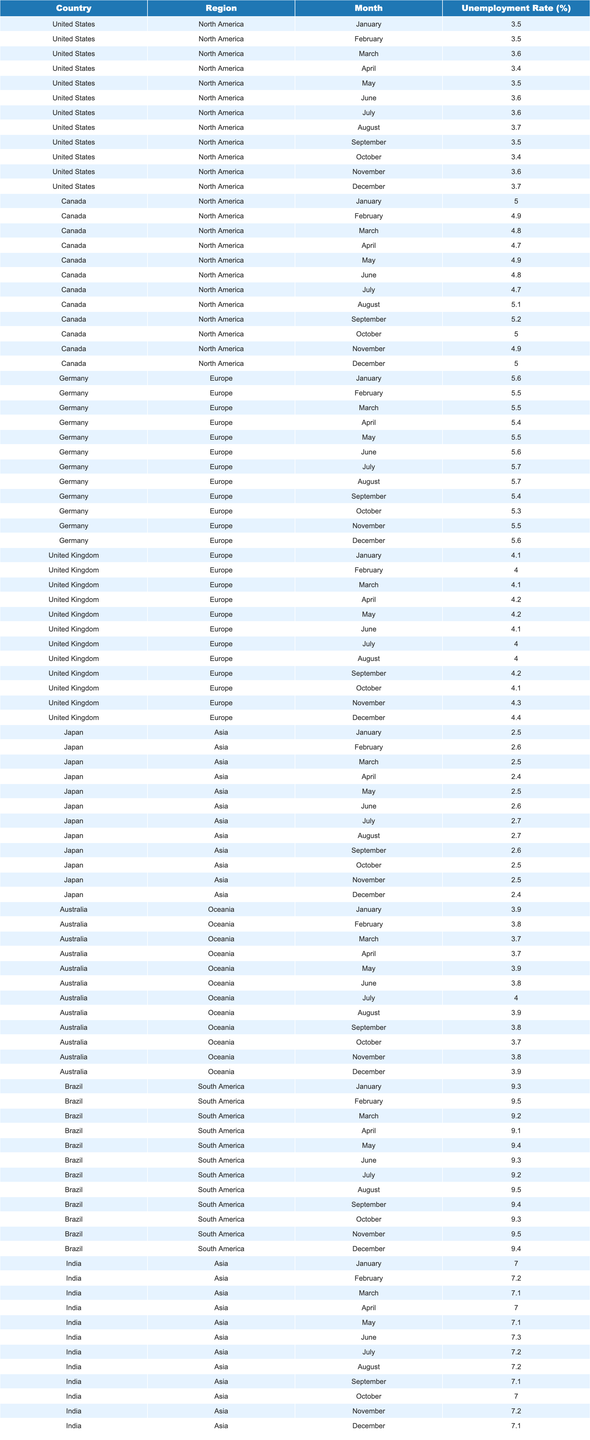What was the highest unemployment rate in Brazil in 2023? By reviewing the data for Brazil, the highest unemployment rate occurred in February at 9.5%.
Answer: 9.5% Which country had the lowest average unemployment rate in 2023? To find this, we calculate the average for each country: United States (3.55%), Japan (2.55%), Australia (3.83%), Canada (4.91%), Germany (5.42%), United Kingdom (4.14%), Brazil (9.36%), and India (7.12%). Japan has the lowest average at 2.55%.
Answer: Japan Did the unemployment rate in the United States ever exceed 3.7% during 2023? By examining the U.S. unemployment rates, the maximum recorded is 3.7% in August and December, indicating it did not exceed this value.
Answer: No What was the percentage decrease in unemployment rate in India from January to April 2023? India's unemployment rate in January was 7.0% and in April it was also 7.0%. The percentage decrease is calculated based on these numbers, which shows that there was no decrease.
Answer: 0% Which month saw the highest unemployment rate in Canada, and what was it? In analyzing the Canadian data, August has the highest unemployment rate at 5.1% during that month.
Answer: 5.1% in August What is the average unemployment rate for Europe in 2023? To find the average for Europe, we compute the mean of Germany 5.6%, 5.5%, 5.5%, 5.4%, 5.5%, 5.6%, 5.7%, 5.7%, 5.4%, 5.3%, 5.5%, 5.6% and United Kingdom 4.1%, 4.0%, 4.1%, 4.2%, 4.2%, 4.1%, 4.0%, 4.0%, 4.2%, 4.1%, 4.3%, 4.4%. Totaling to (5.5*12 + 4.1*12)/24 = 4.83 approximately.
Answer: 4.83% Which region experienced the highest unemployment rate in December 2023? In December, Brazil (9.4%), Canada (5.0%), Germany (5.6%), United Kingdom (4.4%), Japan (2.4%), and Australia (3.9%). Brazil has the highest rate at 9.4%.
Answer: South America (Brazil) How many months had unemployment rates above 4% in Germany? In Germany, the unemployment rates over 4% occurred in every month, totaling 12 months with rates at 5.3% and higher.
Answer: 12 months If we consider the unemployment rates in Asia, what is the average for Japan and India combined? The average for Japan (2.5%, 2.6%, 2.5%, 2.4%, 2.5%, 2.6%, 2.7%, 2.7%, 2.6%, 2.5%, 2.5%, 2.4%) is 2.55%, and for India (7.0%, 7.2%, 7.1%, 7.0%, 7.1%, 7.3%, 7.2%, 7.2%, 7.1%, 7.0%, 7.2%, 7.1%) is 7.1%. The combined average is (2.55 + 7.1) / 2 = 4.825%.
Answer: 4.825% Was there an increase in the unemployment rate in Australia from January to April 2023? The unemployment rates in Australia were 3.9% in January and 3.7% in April, showing a decrease rather than an increase.
Answer: No 